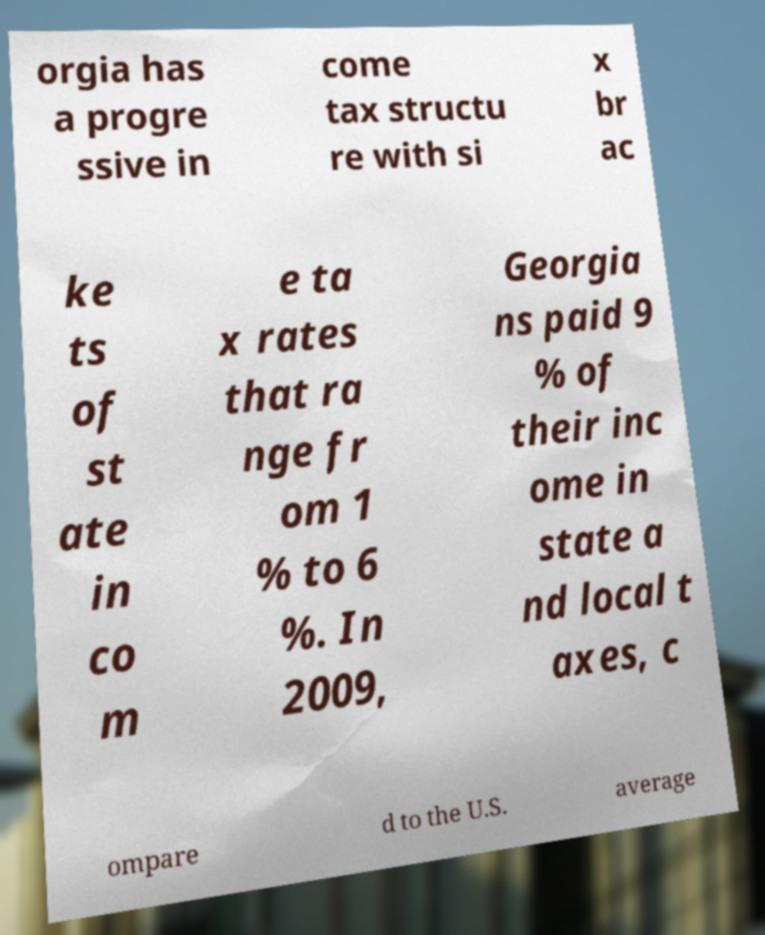Please read and relay the text visible in this image. What does it say? orgia has a progre ssive in come tax structu re with si x br ac ke ts of st ate in co m e ta x rates that ra nge fr om 1 % to 6 %. In 2009, Georgia ns paid 9 % of their inc ome in state a nd local t axes, c ompare d to the U.S. average 